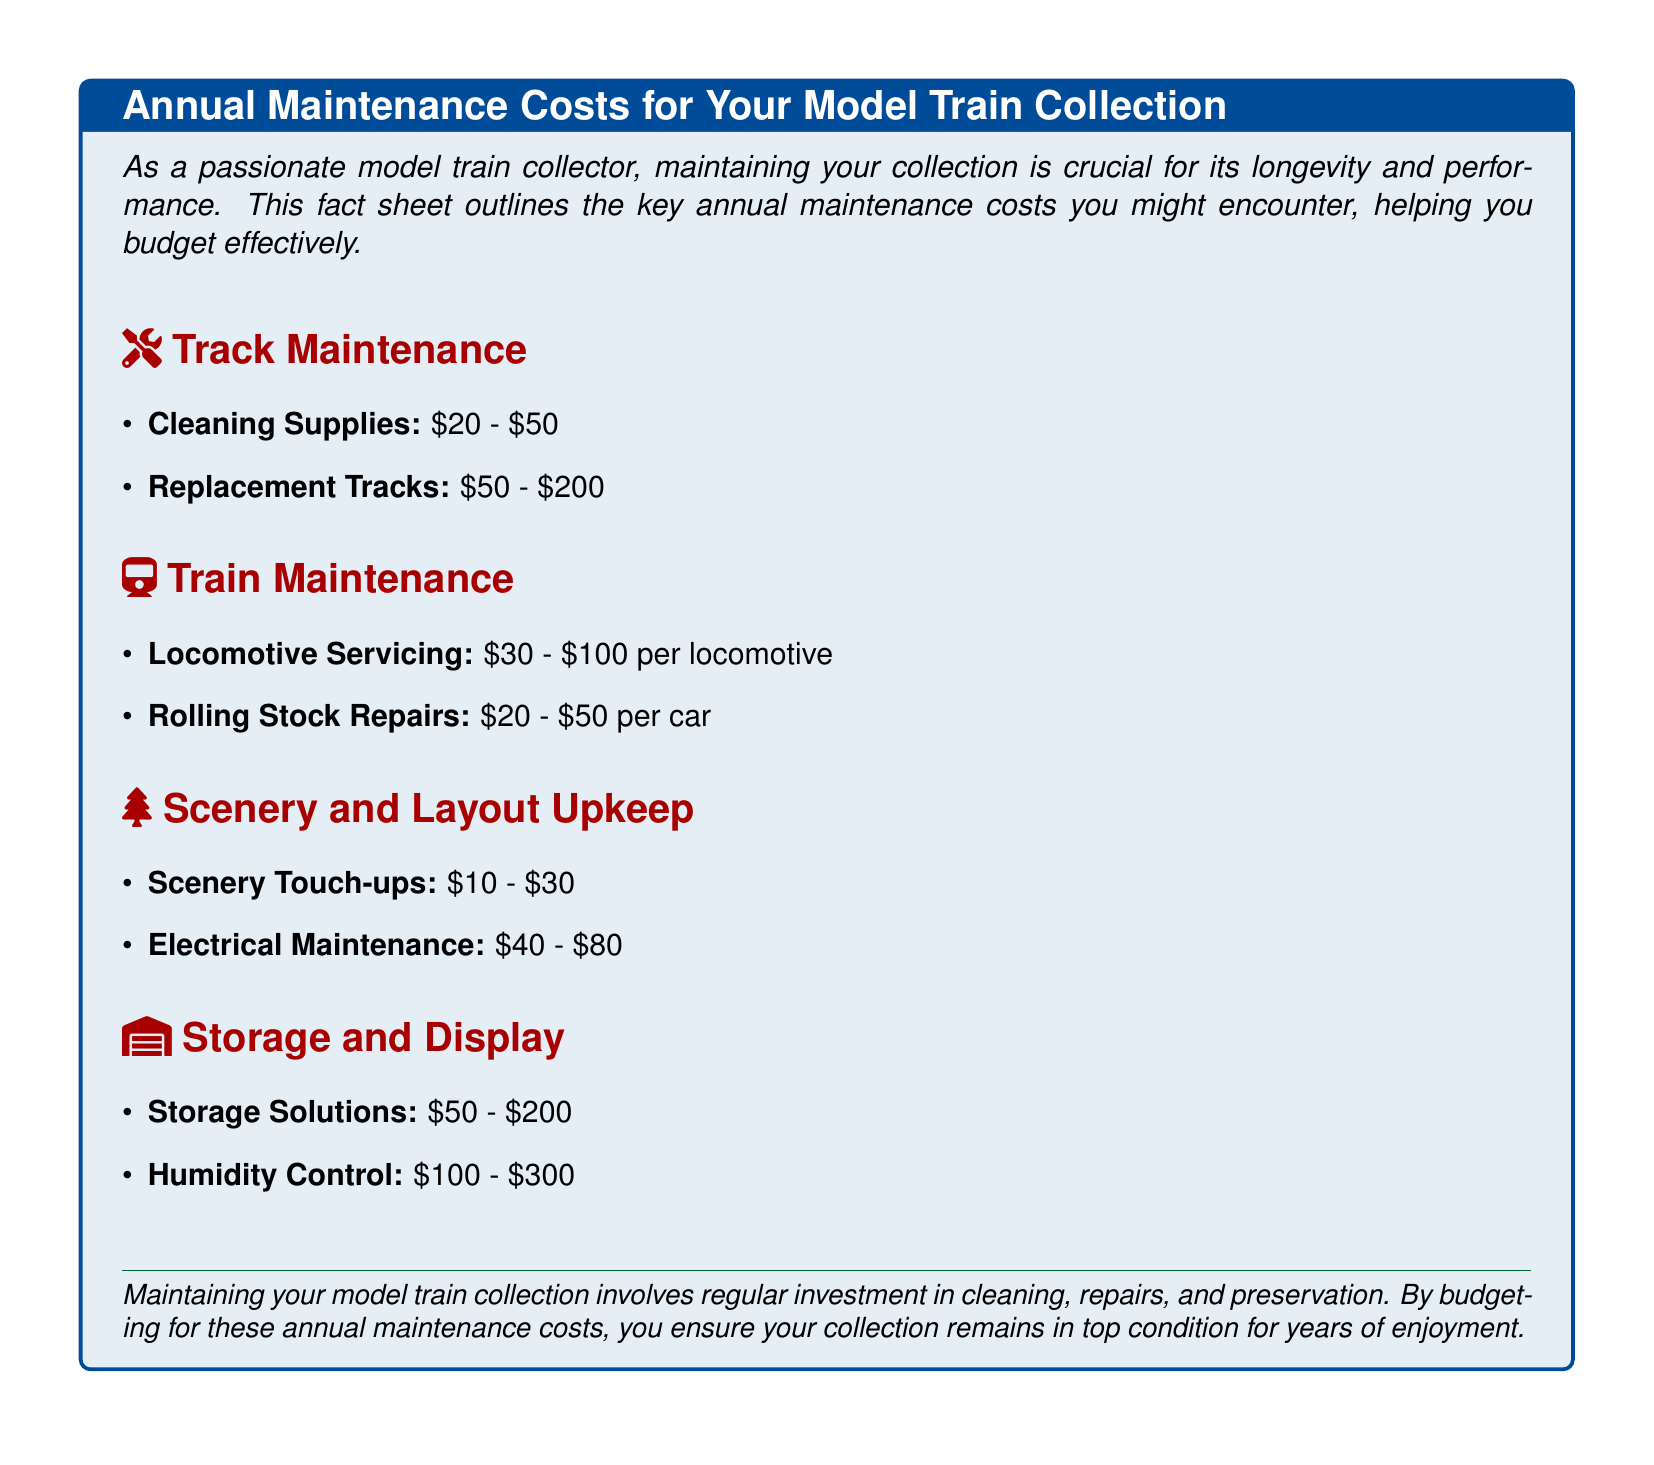what is the range for cleaning supplies? The document states that cleaning supplies cost between $20 and $50.
Answer: $20 - $50 how much does locomotive servicing cost per locomotive? The cost for locomotive servicing as mentioned is between $30 and $100 per locomotive.
Answer: $30 - $100 what is the maximum cost for humidity control? The maximum cost for humidity control is specified to be $300.
Answer: $300 how much can you spend on storage solutions? The document indicates that storage solutions can cost between $50 and $200.
Answer: $50 - $200 what type of maintenance involves scenery touch-ups? Scenery touch-ups are listed under scenery and layout upkeep.
Answer: Scenery and layout upkeep how many categories of maintenance costs are listed? The fact sheet outlines four main categories of maintenance costs: Track, Train, Scenery and Layout, Storage and Display.
Answer: Four what is the minimum cost for electrical maintenance? The minimum cost for electrical maintenance is specified as $40.
Answer: $40 what is the purpose of this fact sheet? The document emphasizes maintaining the collection for longevity and performance.
Answer: Maintaining the collection for longevity and performance what materials are needed for track maintenance? Cleaning supplies and replacement tracks are required for track maintenance.
Answer: Cleaning supplies and replacement tracks 